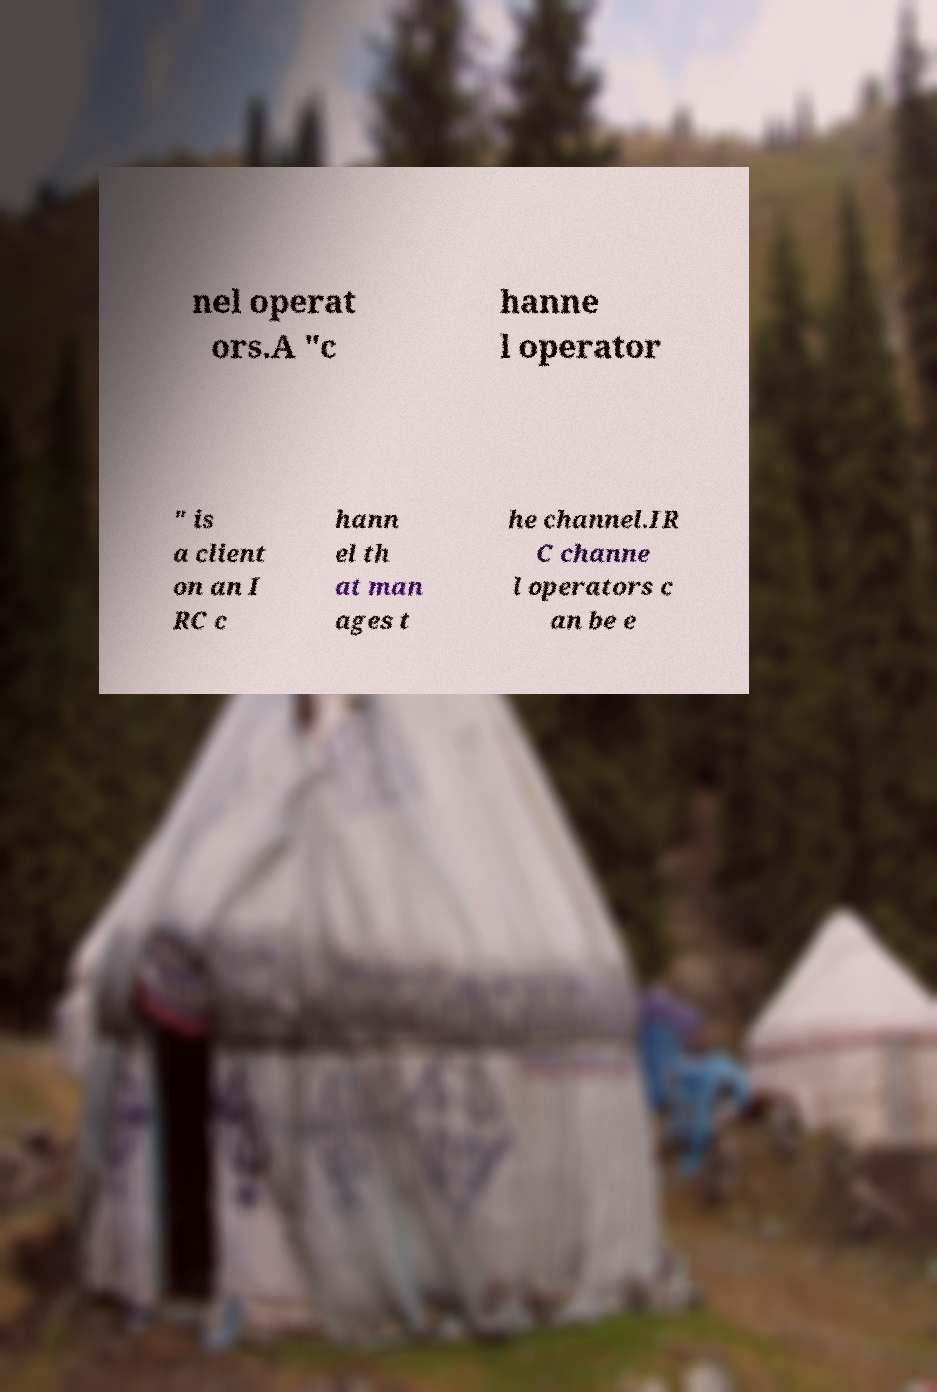What messages or text are displayed in this image? I need them in a readable, typed format. nel operat ors.A "c hanne l operator " is a client on an I RC c hann el th at man ages t he channel.IR C channe l operators c an be e 